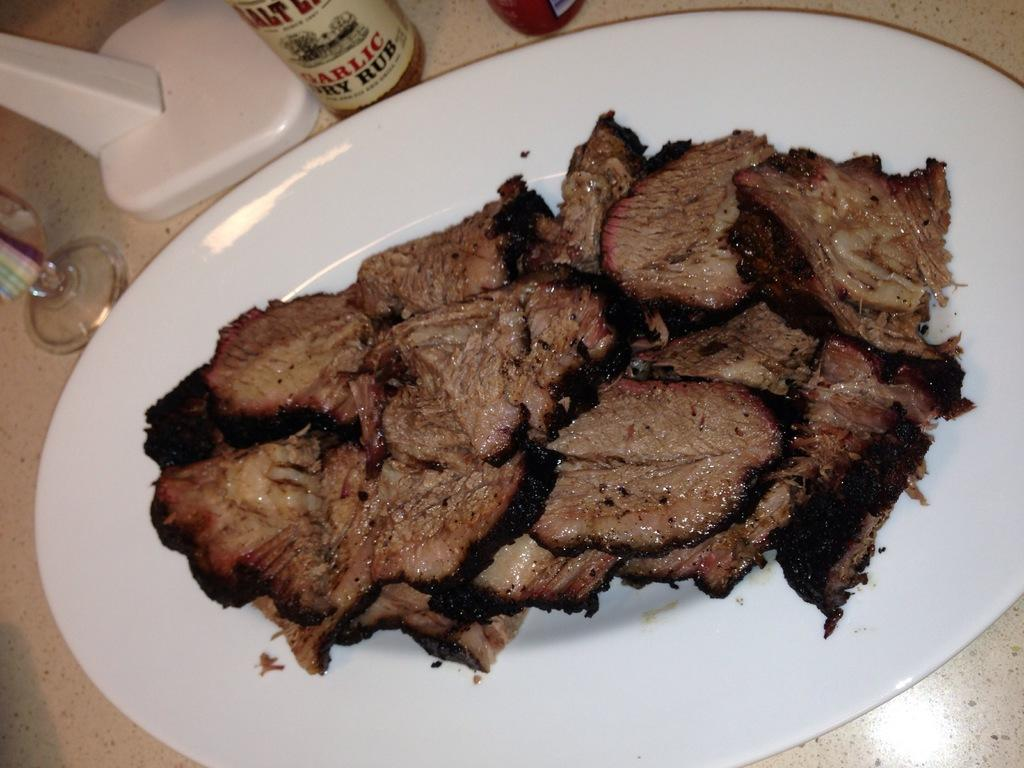Provide a one-sentence caption for the provided image. A bottle of garlic rub sauce for meat. 